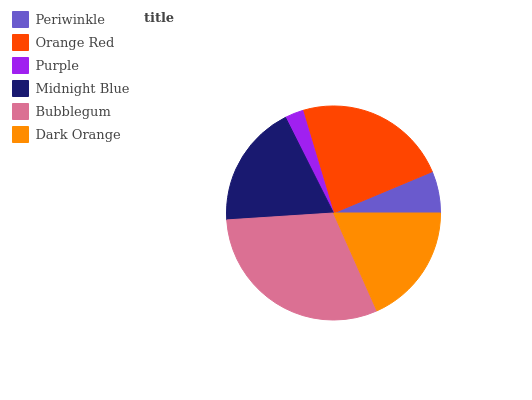Is Purple the minimum?
Answer yes or no. Yes. Is Bubblegum the maximum?
Answer yes or no. Yes. Is Orange Red the minimum?
Answer yes or no. No. Is Orange Red the maximum?
Answer yes or no. No. Is Orange Red greater than Periwinkle?
Answer yes or no. Yes. Is Periwinkle less than Orange Red?
Answer yes or no. Yes. Is Periwinkle greater than Orange Red?
Answer yes or no. No. Is Orange Red less than Periwinkle?
Answer yes or no. No. Is Midnight Blue the high median?
Answer yes or no. Yes. Is Dark Orange the low median?
Answer yes or no. Yes. Is Dark Orange the high median?
Answer yes or no. No. Is Bubblegum the low median?
Answer yes or no. No. 